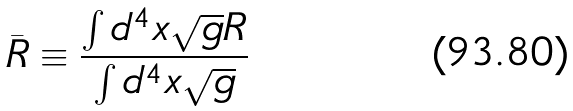Convert formula to latex. <formula><loc_0><loc_0><loc_500><loc_500>\bar { R } \equiv \frac { \int d ^ { 4 } x \sqrt { g } R } { \int d ^ { 4 } x \sqrt { g } }</formula> 